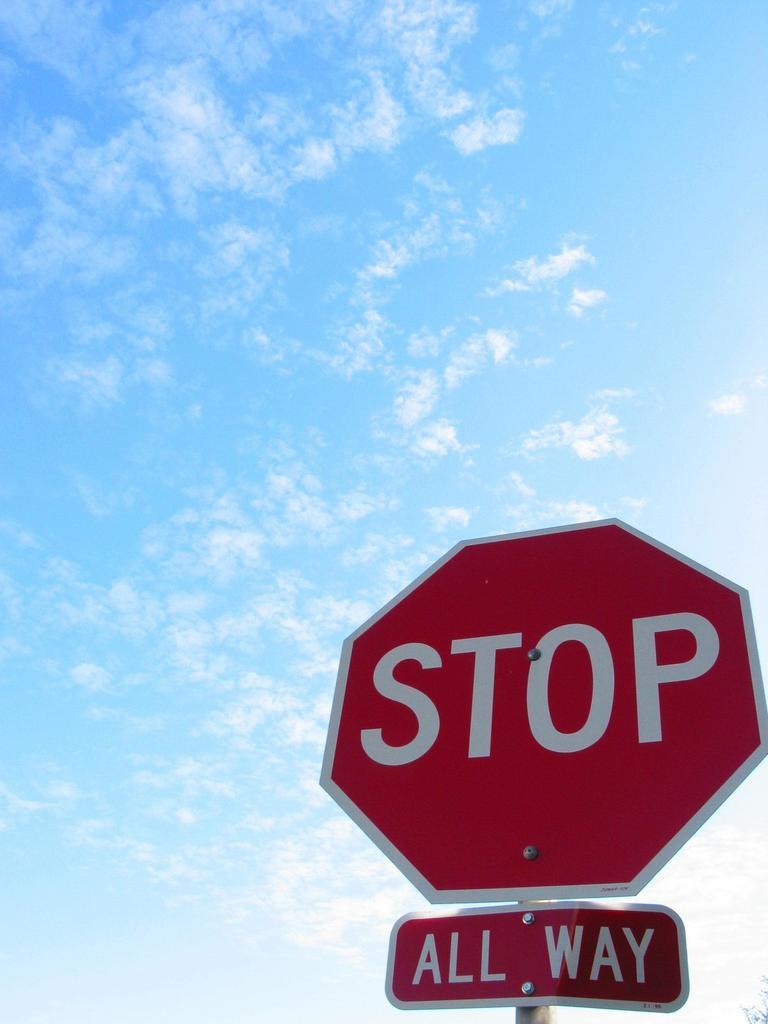What kind of traffic sign is this?
Your answer should be very brief. Stop. What colour is this sign?
Your answer should be compact. Answering does not require reading text in the image. 